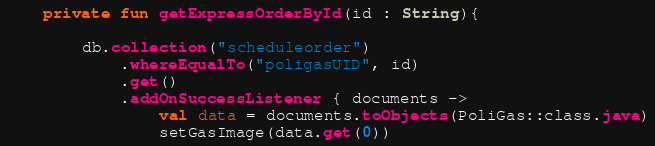Convert code to text. <code><loc_0><loc_0><loc_500><loc_500><_Kotlin_>
    private fun getExpressOrderById(id : String){

        db.collection("scheduleorder")
            .whereEqualTo("poligasUID", id)
            .get()
            .addOnSuccessListener { documents ->
                val data = documents.toObjects(PoliGas::class.java)
                setGasImage(data.get(0))</code> 